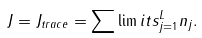Convert formula to latex. <formula><loc_0><loc_0><loc_500><loc_500>J = J _ { t r a c e } = \sum \lim i t s _ { j = 1 } ^ { L } n _ { j } .</formula> 